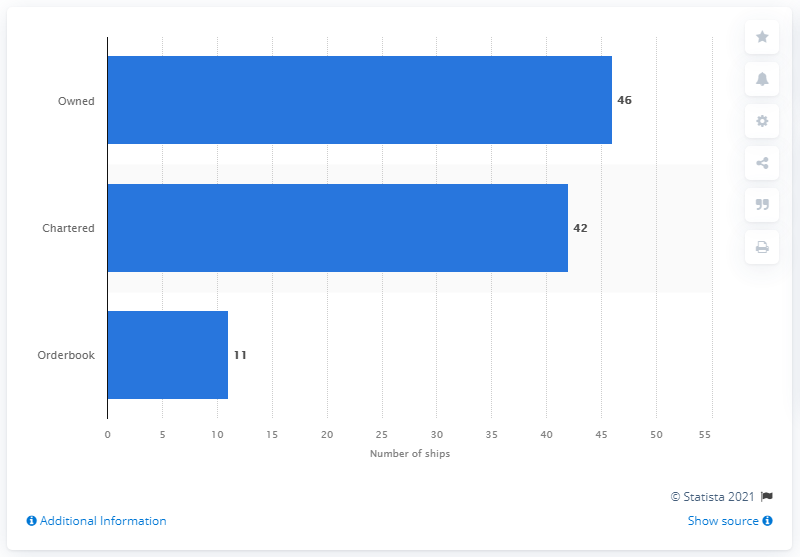Specify some key components in this picture. There were 46 ships in Yang Ming's fleet that were owned by the company. Forty-two ships were chartered by Yang Ming. 